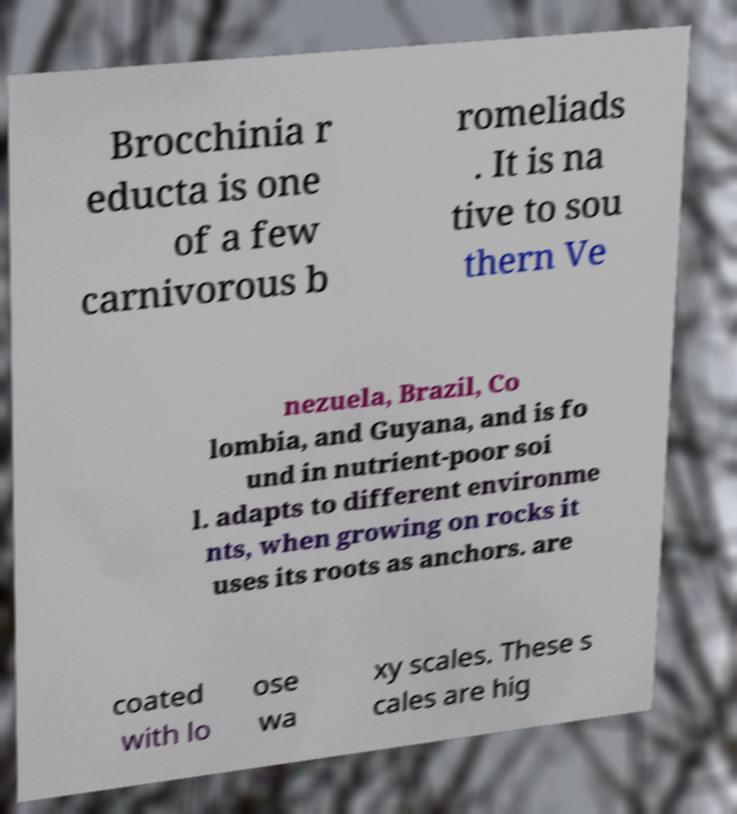Can you read and provide the text displayed in the image?This photo seems to have some interesting text. Can you extract and type it out for me? Brocchinia r educta is one of a few carnivorous b romeliads . It is na tive to sou thern Ve nezuela, Brazil, Co lombia, and Guyana, and is fo und in nutrient-poor soi l. adapts to different environme nts, when growing on rocks it uses its roots as anchors. are coated with lo ose wa xy scales. These s cales are hig 